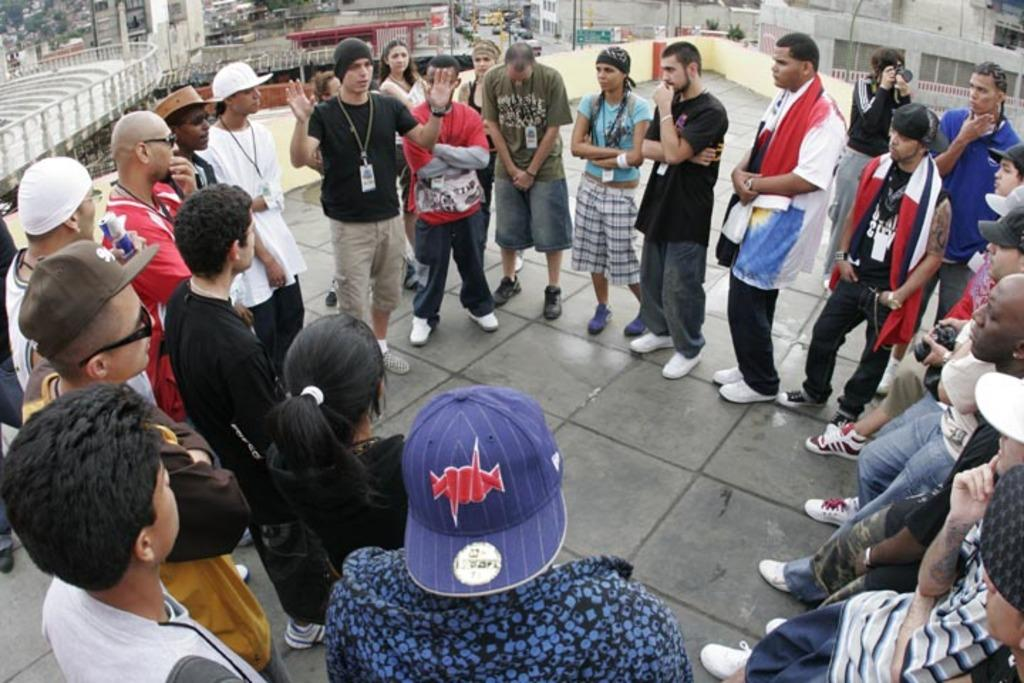What is happening in the image? There are people standing in the image, and one person is talking among them. What can be seen in the background of the image? There are buildings in the background of the image. What type of bottle is being used by the person talking in the image? There is no bottle present in the image; the person talking is not holding or using any bottle. 